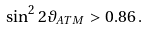Convert formula to latex. <formula><loc_0><loc_0><loc_500><loc_500>\sin ^ { 2 } 2 \vartheta _ { A T M } > 0 . 8 6 \, .</formula> 